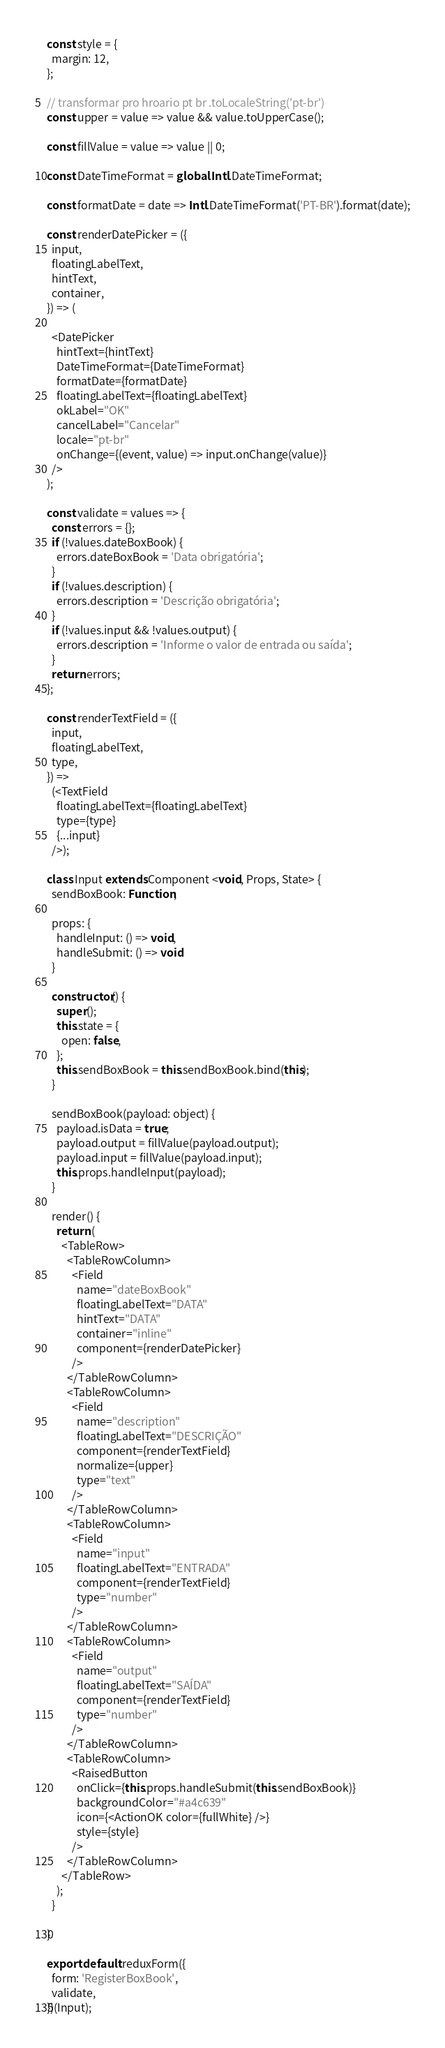<code> <loc_0><loc_0><loc_500><loc_500><_JavaScript_>const style = {
  margin: 12,
};

// transformar pro hroario pt br .toLocaleString('pt-br')
const upper = value => value && value.toUpperCase();

const fillValue = value => value || 0;

const DateTimeFormat = global.Intl.DateTimeFormat;

const formatDate = date => Intl.DateTimeFormat('PT-BR').format(date);

const renderDatePicker = ({
  input,
  floatingLabelText,
  hintText,
  container,
}) => (

  <DatePicker
    hintText={hintText}
    DateTimeFormat={DateTimeFormat}
    formatDate={formatDate}
    floatingLabelText={floatingLabelText}
    okLabel="OK"
    cancelLabel="Cancelar"
    locale="pt-br"
    onChange={(event, value) => input.onChange(value)}
  />
);

const validate = values => {
  const errors = {};
  if (!values.dateBoxBook) {
    errors.dateBoxBook = 'Data obrigatória';
  }
  if (!values.description) {
    errors.description = 'Descrição obrigatória';
  }
  if (!values.input && !values.output) {
    errors.description = 'Informe o valor de entrada ou saída';
  }
  return errors;
};

const renderTextField = ({
  input,
  floatingLabelText,
  type,
}) =>
  (<TextField
    floatingLabelText={floatingLabelText}
    type={type}
    {...input}
  />);

class Input extends Component <void, Props, State> {
  sendBoxBook: Function;

  props: {
    handleInput: () => void,
    handleSubmit: () => void
  }

  constructor() {
    super();
    this.state = {
      open: false,
    };
    this.sendBoxBook = this.sendBoxBook.bind(this);
  }

  sendBoxBook(payload: object) {
    payload.isData = true;
    payload.output = fillValue(payload.output);
    payload.input = fillValue(payload.input);
    this.props.handleInput(payload);
  }

  render() {
    return (
      <TableRow>
        <TableRowColumn>
          <Field
            name="dateBoxBook"
            floatingLabelText="DATA"
            hintText="DATA"
            container="inline"
            component={renderDatePicker}
          />
        </TableRowColumn>
        <TableRowColumn>
          <Field
            name="description"
            floatingLabelText="DESCRIÇÃO"
            component={renderTextField}
            normalize={upper}
            type="text"
          />
        </TableRowColumn>
        <TableRowColumn>
          <Field
            name="input"
            floatingLabelText="ENTRADA"
            component={renderTextField}
            type="number"
          />
        </TableRowColumn>
        <TableRowColumn>
          <Field
            name="output"
            floatingLabelText="SAÍDA"
            component={renderTextField}
            type="number"
          />
        </TableRowColumn>
        <TableRowColumn>
          <RaisedButton
            onClick={this.props.handleSubmit(this.sendBoxBook)}
            backgroundColor="#a4c639"
            icon={<ActionOK color={fullWhite} />}
            style={style}
          />
        </TableRowColumn>
      </TableRow>
    );
  }

}

export default reduxForm({
  form: 'RegisterBoxBook',
  validate,
})(Input);

</code> 